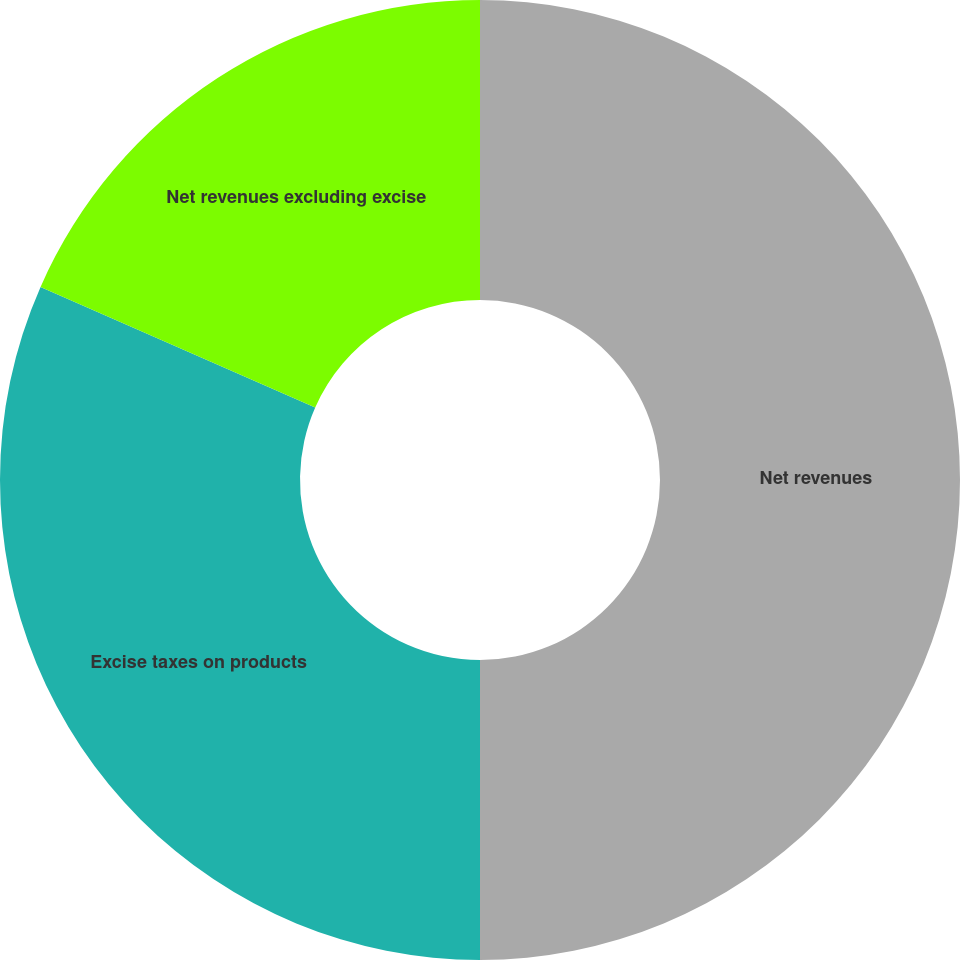Convert chart. <chart><loc_0><loc_0><loc_500><loc_500><pie_chart><fcel>Net revenues<fcel>Excise taxes on products<fcel>Net revenues excluding excise<nl><fcel>50.0%<fcel>31.59%<fcel>18.41%<nl></chart> 